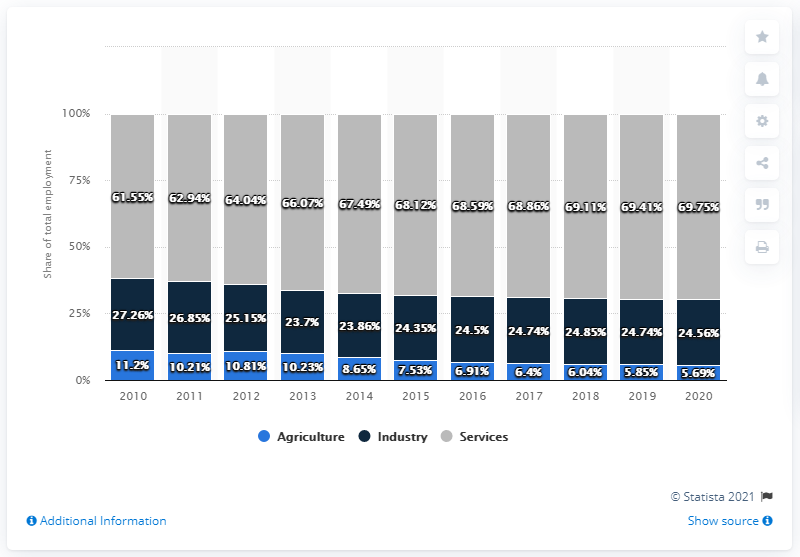Highlight a few significant elements in this photo. The distribution of industry and services in 2010 differed. 